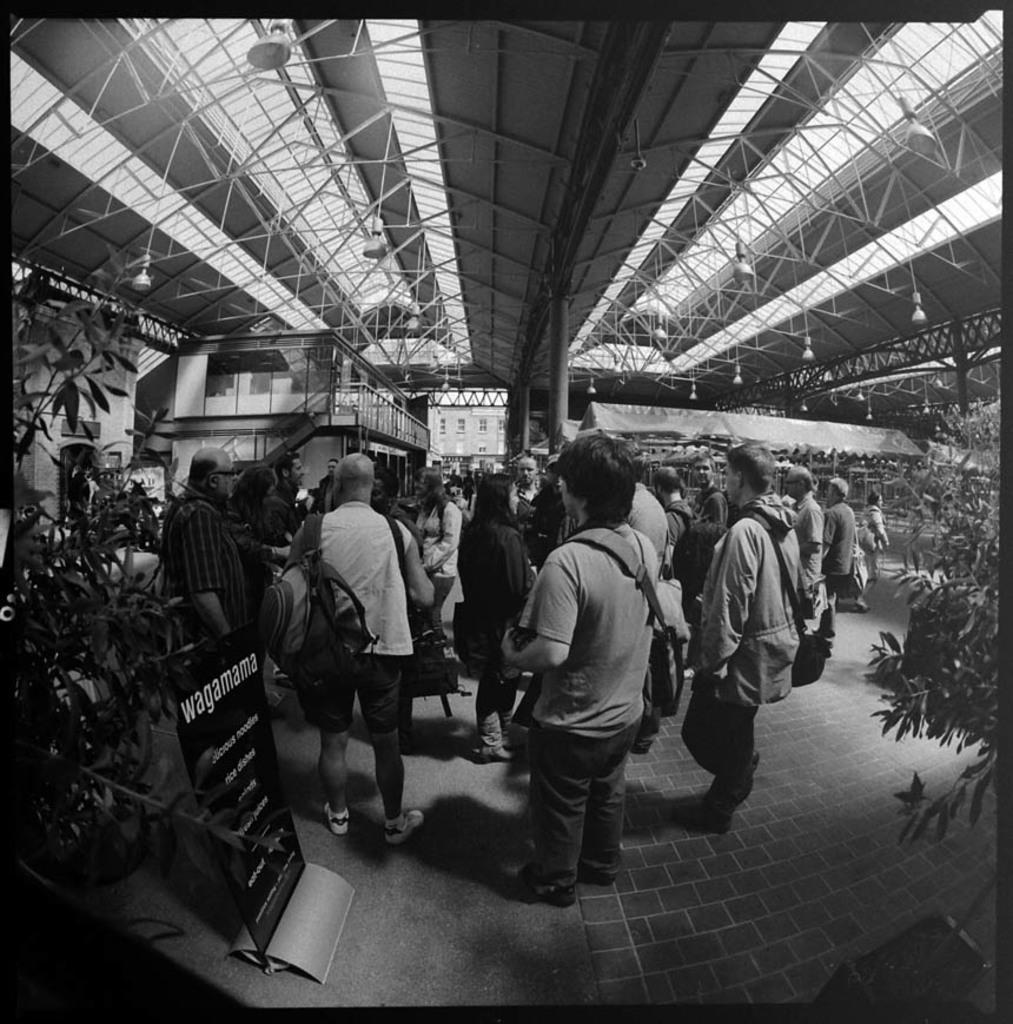How many people are in the group that is visible in the image? There is a group of people standing in the image, but the exact number is not specified. What else can be seen in the image besides the group of people? There are plants, a board, a wall, windows, pillars, and lights visible in the image. Can you describe the background of the image? The background of the image includes a wall, windows, and pillars. What is the purpose of the board in the image? The purpose of the board in the image is not specified. Where are the lights located in the image? The lights are visible at the top of the image. What type of sail is being used by the people in the image? There is no sail present in the image; it features a group of people standing with various other objects and structures. 